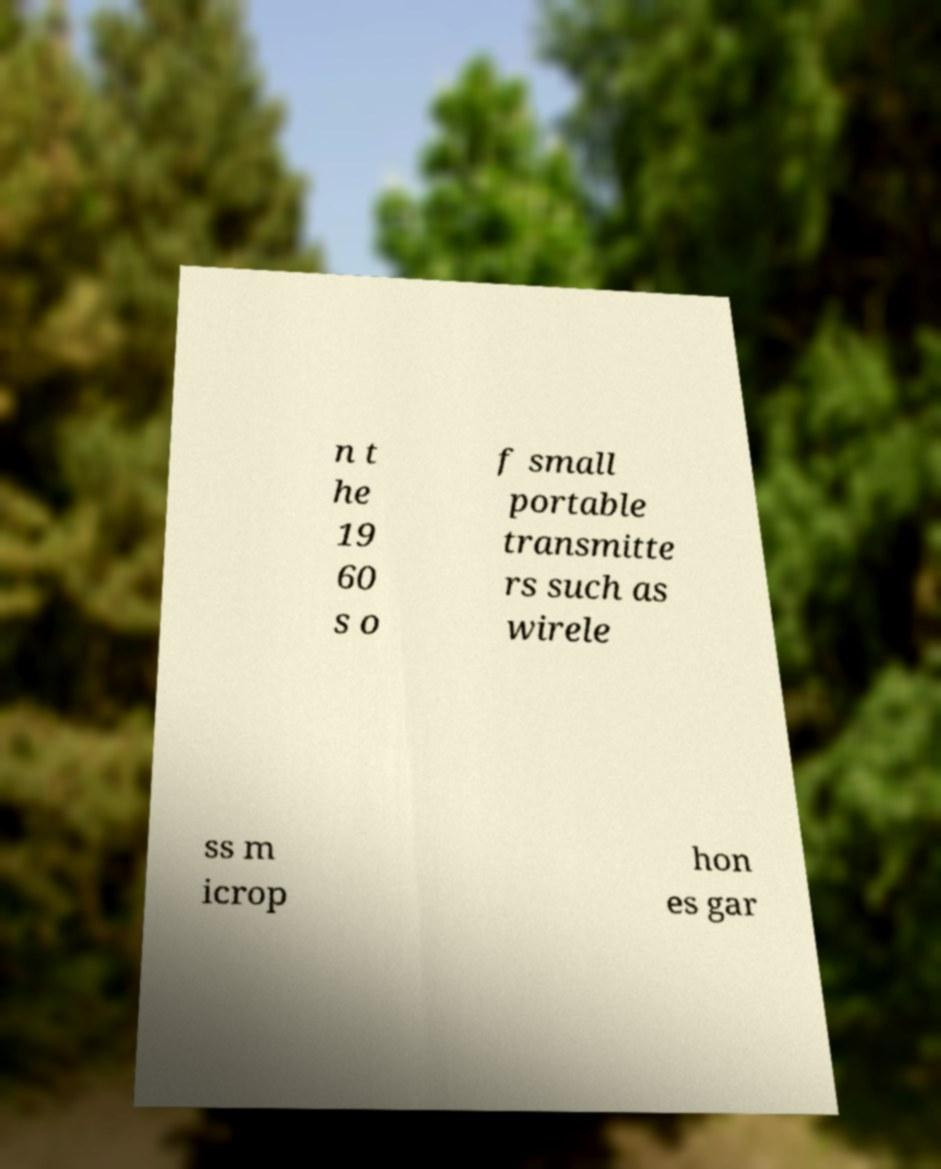Please identify and transcribe the text found in this image. n t he 19 60 s o f small portable transmitte rs such as wirele ss m icrop hon es gar 